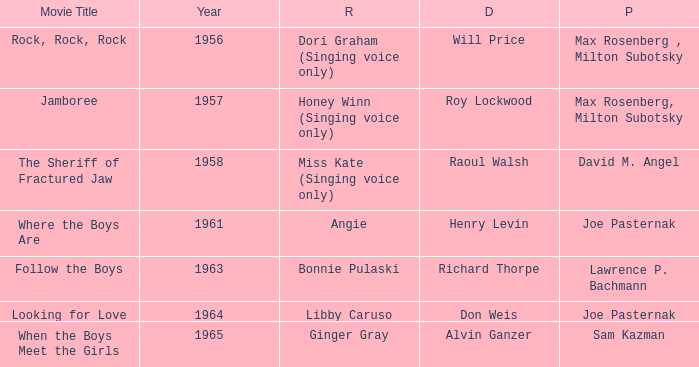What year was Jamboree made? 1957.0. 